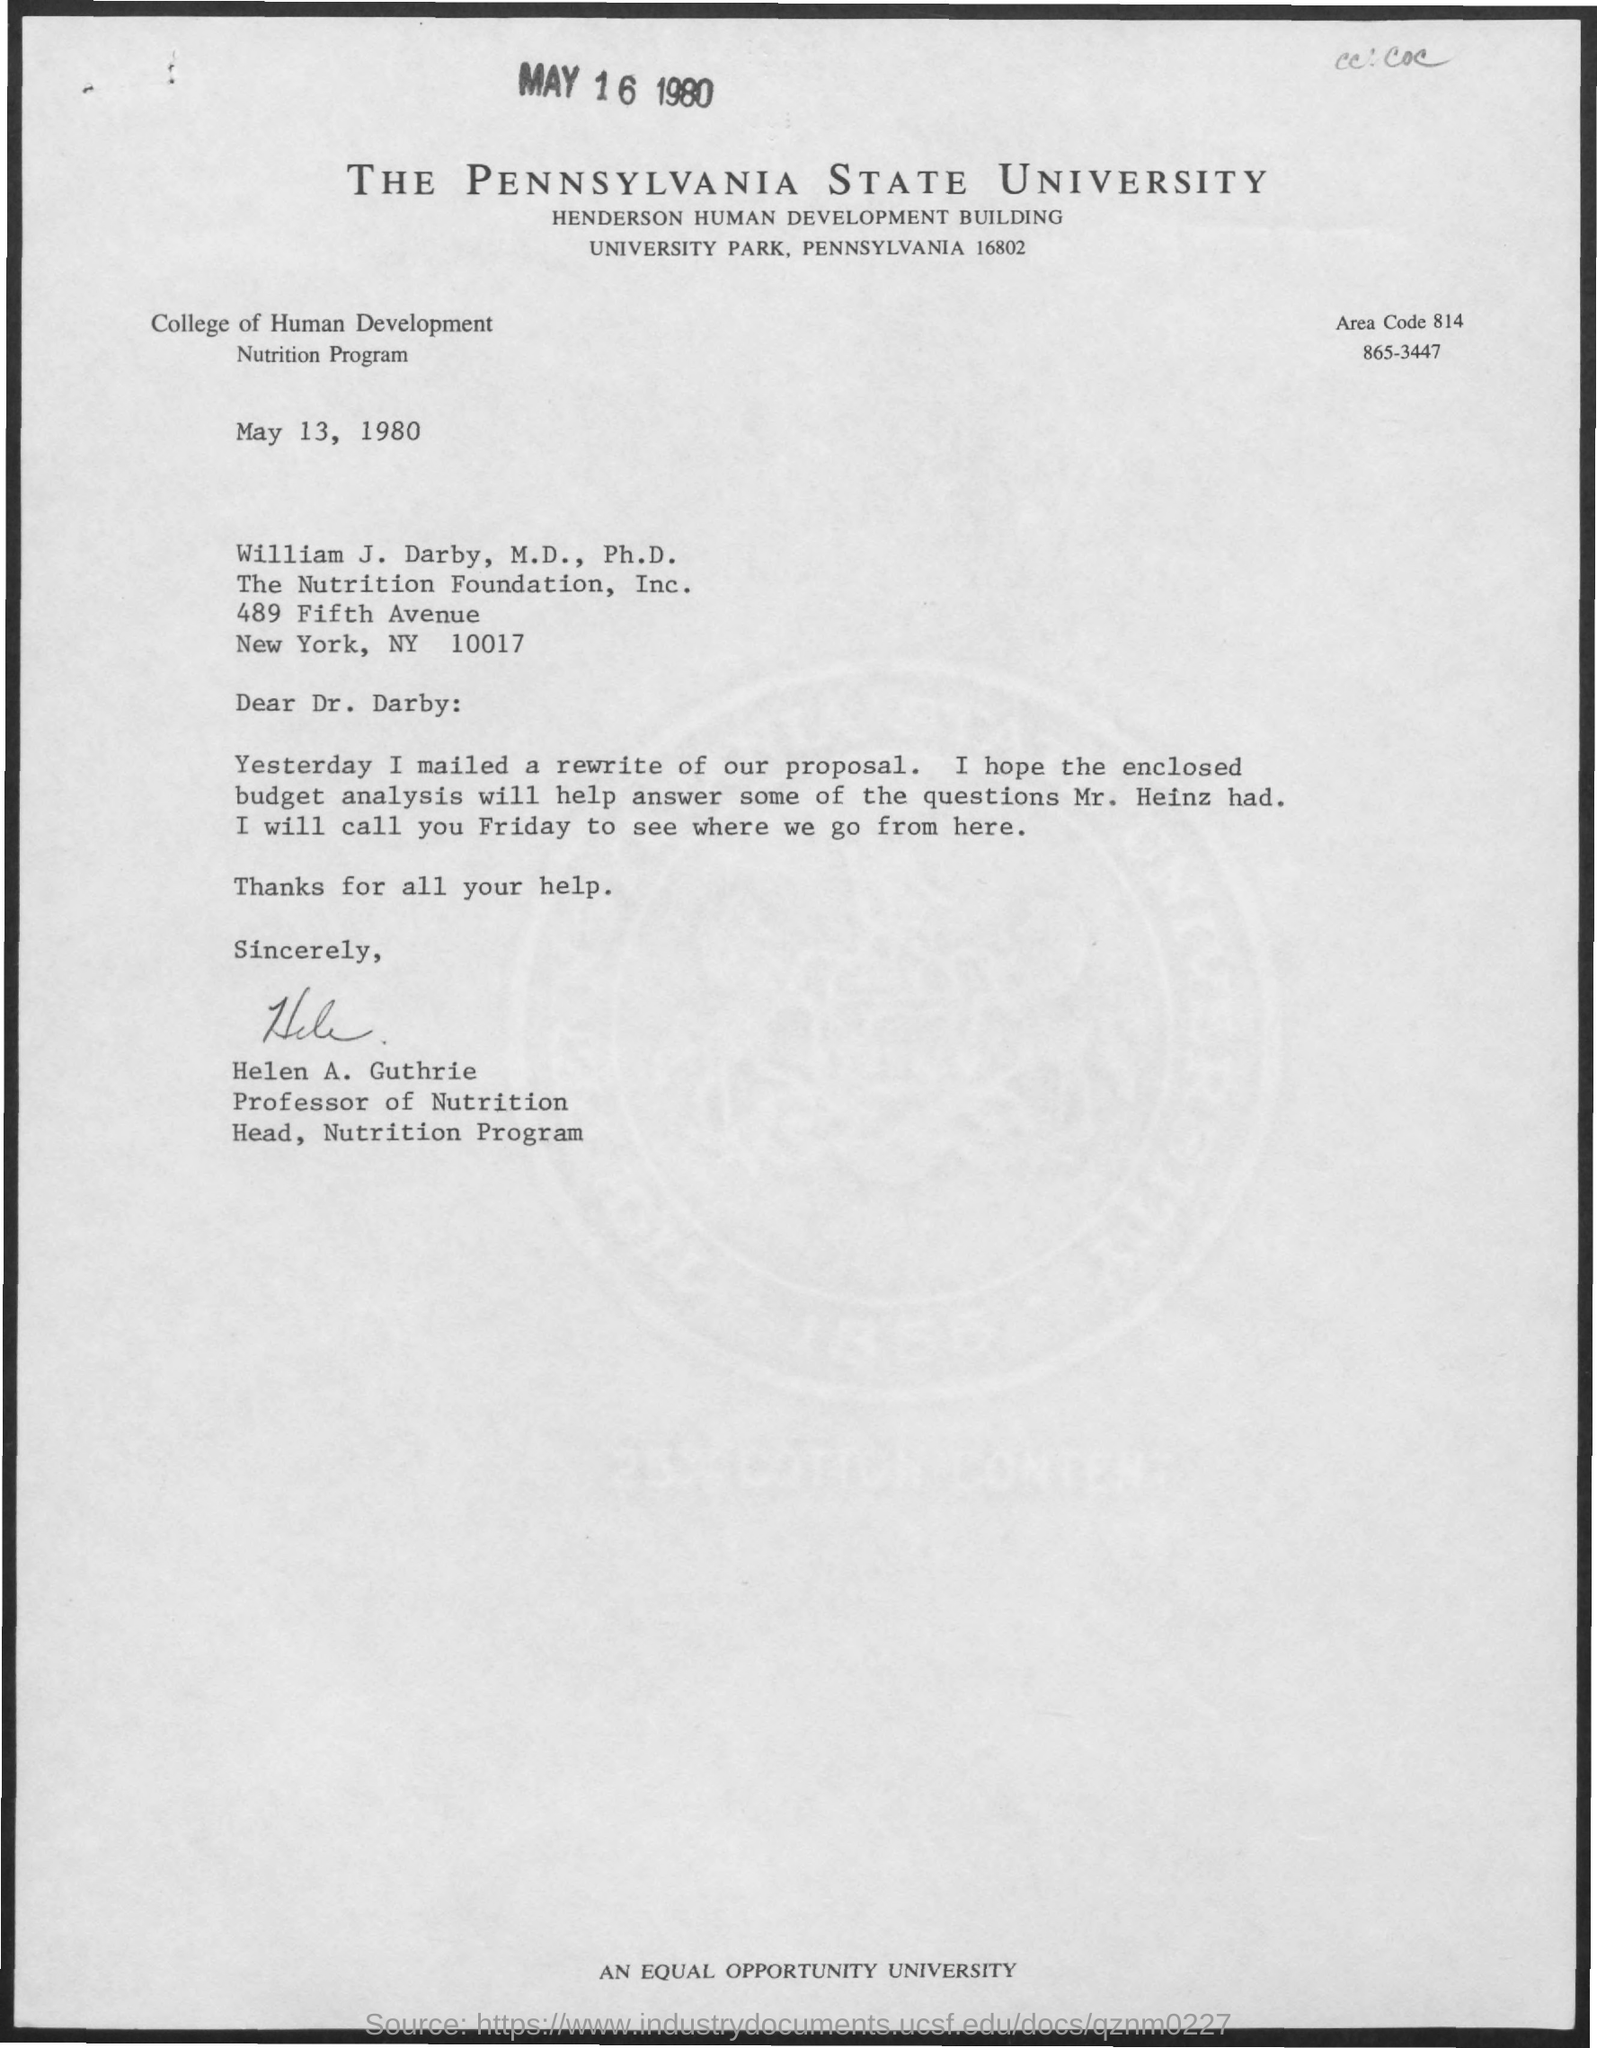List a handful of essential elements in this visual. The date mentioned at the top of the page is May 16, 1980. The area code mentioned in the given form is 814.. The Pennsylvania State University is mentioned in the given form. The Henderson Human Development Building is a notable building. The College of Human Development is a prominent college that is known for its exceptional education and research in the field of human development. 